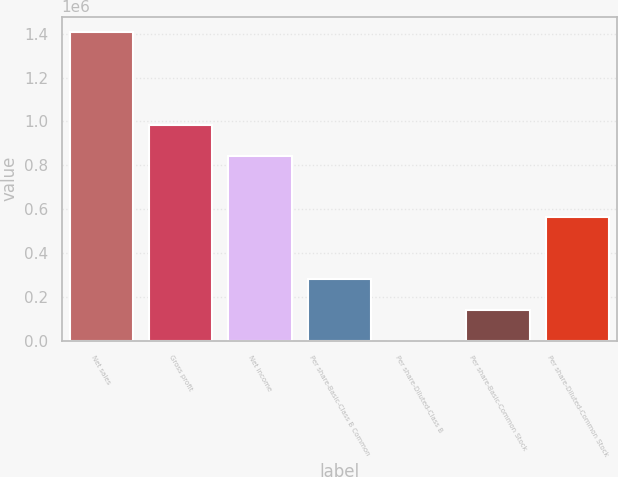Convert chart to OTSL. <chart><loc_0><loc_0><loc_500><loc_500><bar_chart><fcel>Net sales<fcel>Gross profit<fcel>Net income<fcel>Per share-Basic-Class B Common<fcel>Per share-Diluted-Class B<fcel>Per share-Basic-Common Stock<fcel>Per share-Diluted-Common Stock<nl><fcel>1.40734e+06<fcel>985135<fcel>844402<fcel>281467<fcel>0.33<fcel>140734<fcel>562935<nl></chart> 